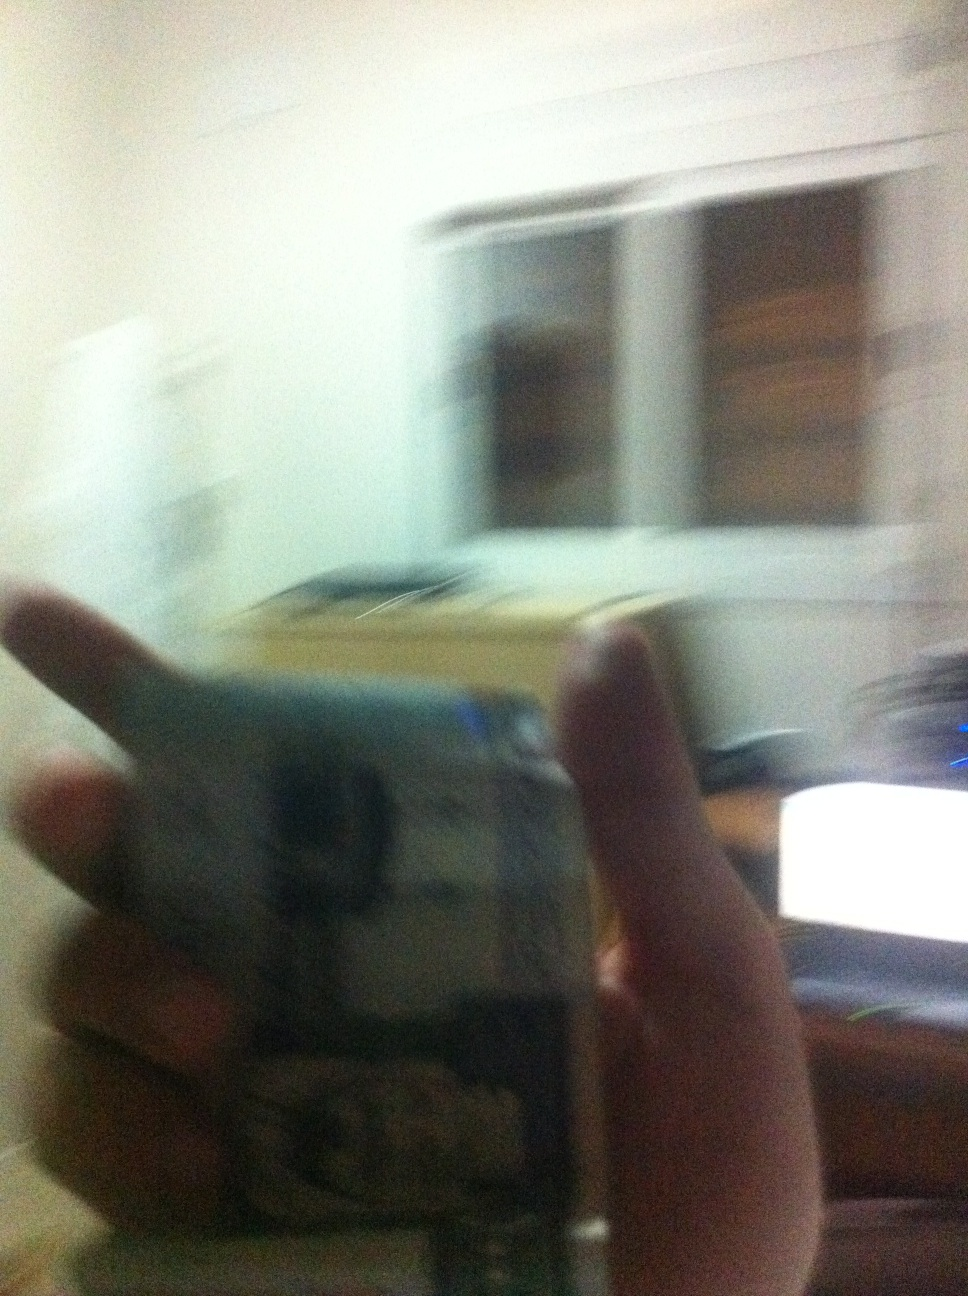What humorous situation could be imagined in the room from this image? Imagine someone in the room trying to shoo away a stubborn fly with a rolled-up newspaper. In their frenzy, they accidentally knock over a cup of coffee, which spills all over their desk and computer. In a slapstick chain reaction, the coffee short-circuits the computer, leading to a frantic and disoriented scene of chaos and laughter. 